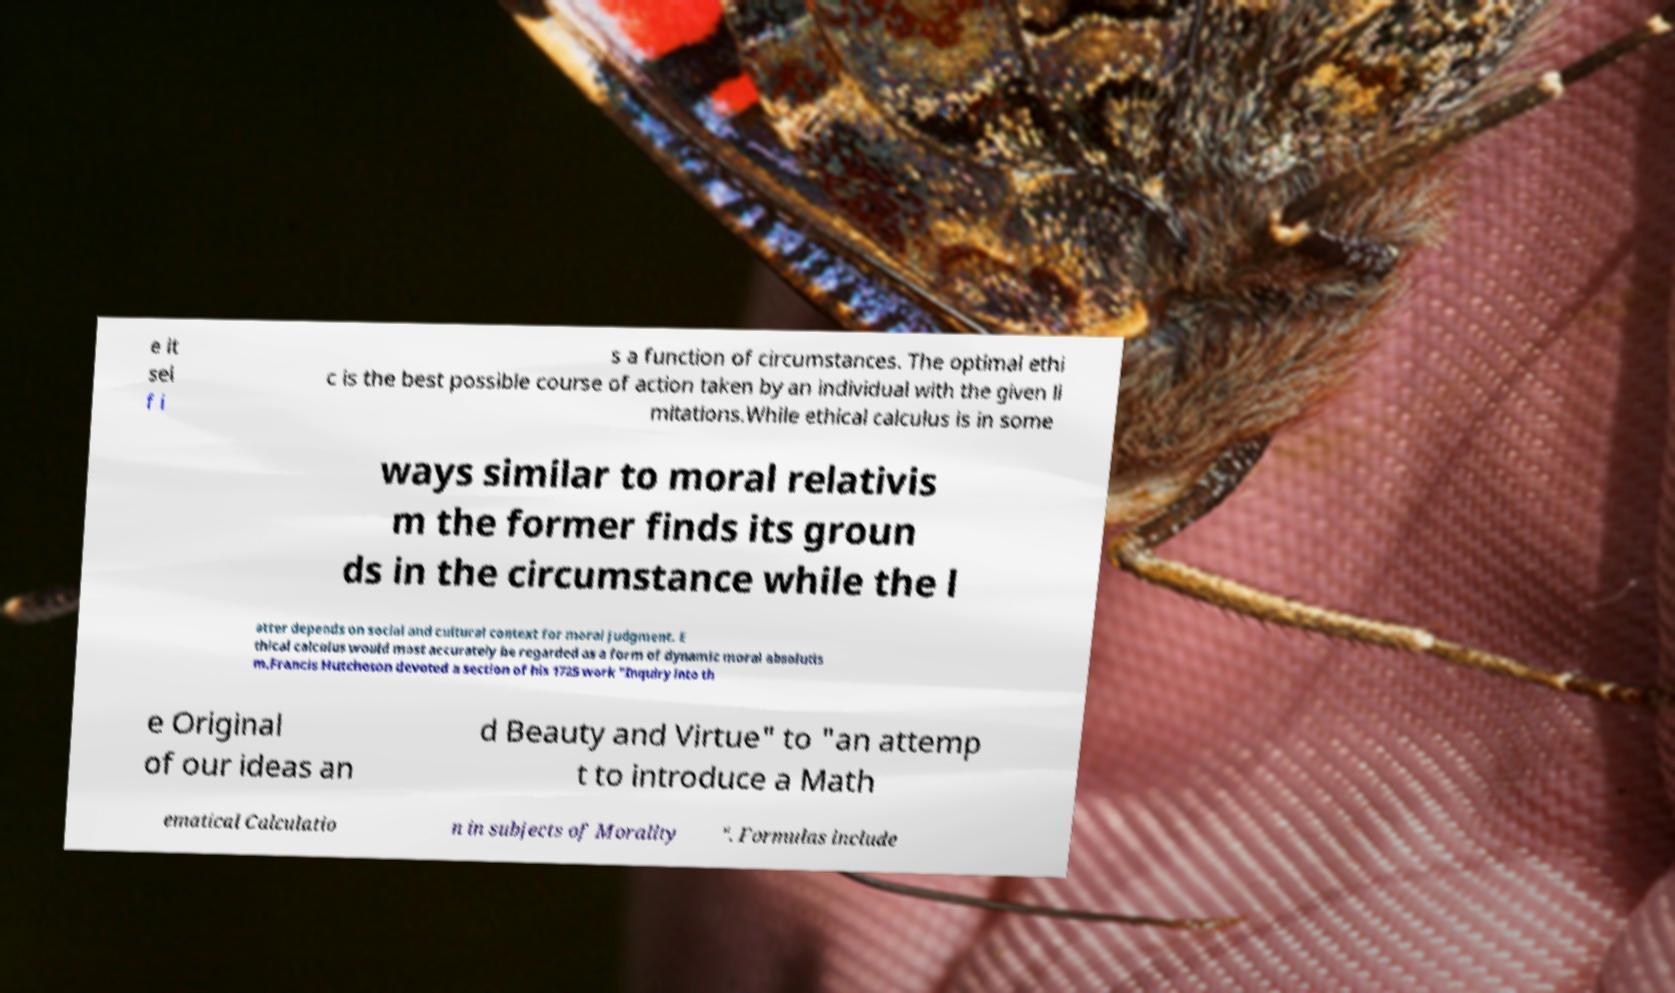There's text embedded in this image that I need extracted. Can you transcribe it verbatim? e it sel f i s a function of circumstances. The optimal ethi c is the best possible course of action taken by an individual with the given li mitations.While ethical calculus is in some ways similar to moral relativis m the former finds its groun ds in the circumstance while the l atter depends on social and cultural context for moral judgment. E thical calculus would most accurately be regarded as a form of dynamic moral absolutis m.Francis Hutcheson devoted a section of his 1725 work "Inquiry into th e Original of our ideas an d Beauty and Virtue" to "an attemp t to introduce a Math ematical Calculatio n in subjects of Morality ". Formulas include 